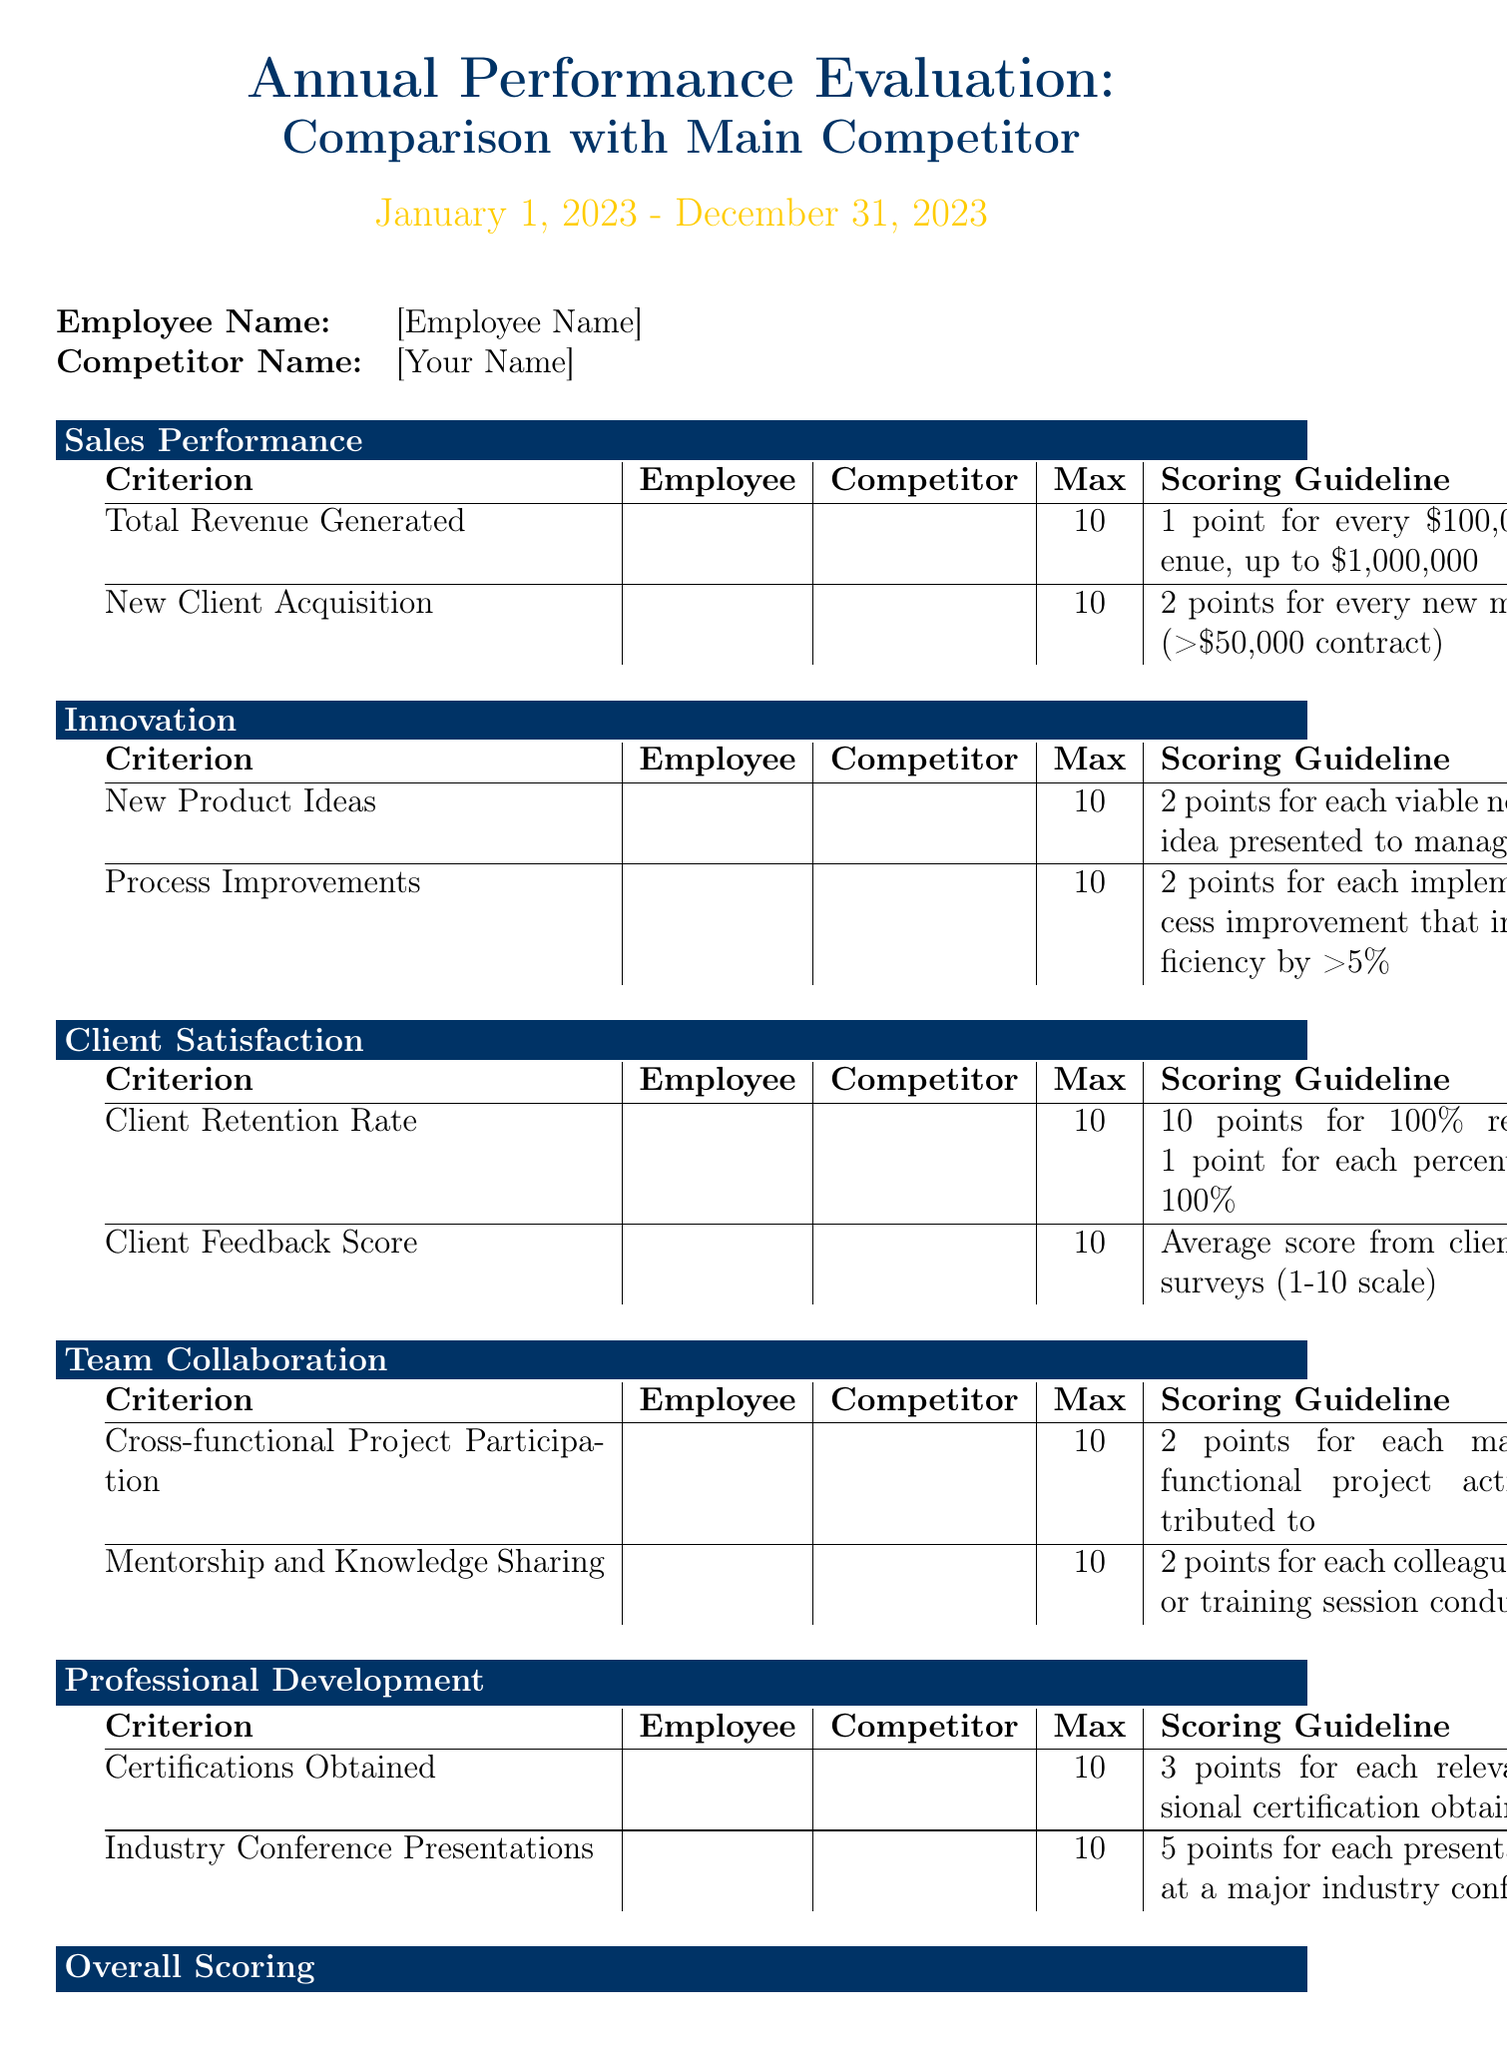what is the evaluation period? The evaluation period is specified in the document as the timeframe for assessment.
Answer: January 1, 2023 - December 31, 2023 who is the employee being evaluated? The employee name is provided at the beginning of the document for identification.
Answer: [Employee Name] how many criteria are there in the Sales Performance category? The document lists two criteria under the Sales Performance category, which are total revenue and new client acquisition.
Answer: 2 what is the maximum score for Client Retention Rate? The document outlines the maximum possible score for each criterion, including client retention.
Answer: 10 how many points are awarded for each new major client acquired? The scoring guideline for new client acquisition specifies how points are assigned based on the criterion.
Answer: 2 points what is the maximum possible score for the evaluation? The document mentions the maximum possible score to evaluate overall performance.
Answer: 100 what are the employee strengths mentioned in the evaluator comments? The document allows space for the evaluator to write comments on employee strengths.
Answer: (Not specified) what is the scoring guideline for certifications obtained? Each criterion has a scoring guideline, and this one specifies points awarded for obtaining certifications.
Answer: 3 points for each relevant professional certification obtained who evaluates the document? The document provides a section for the evaluator's name, indicating who completed the assessment.
Answer: (Not specified) 